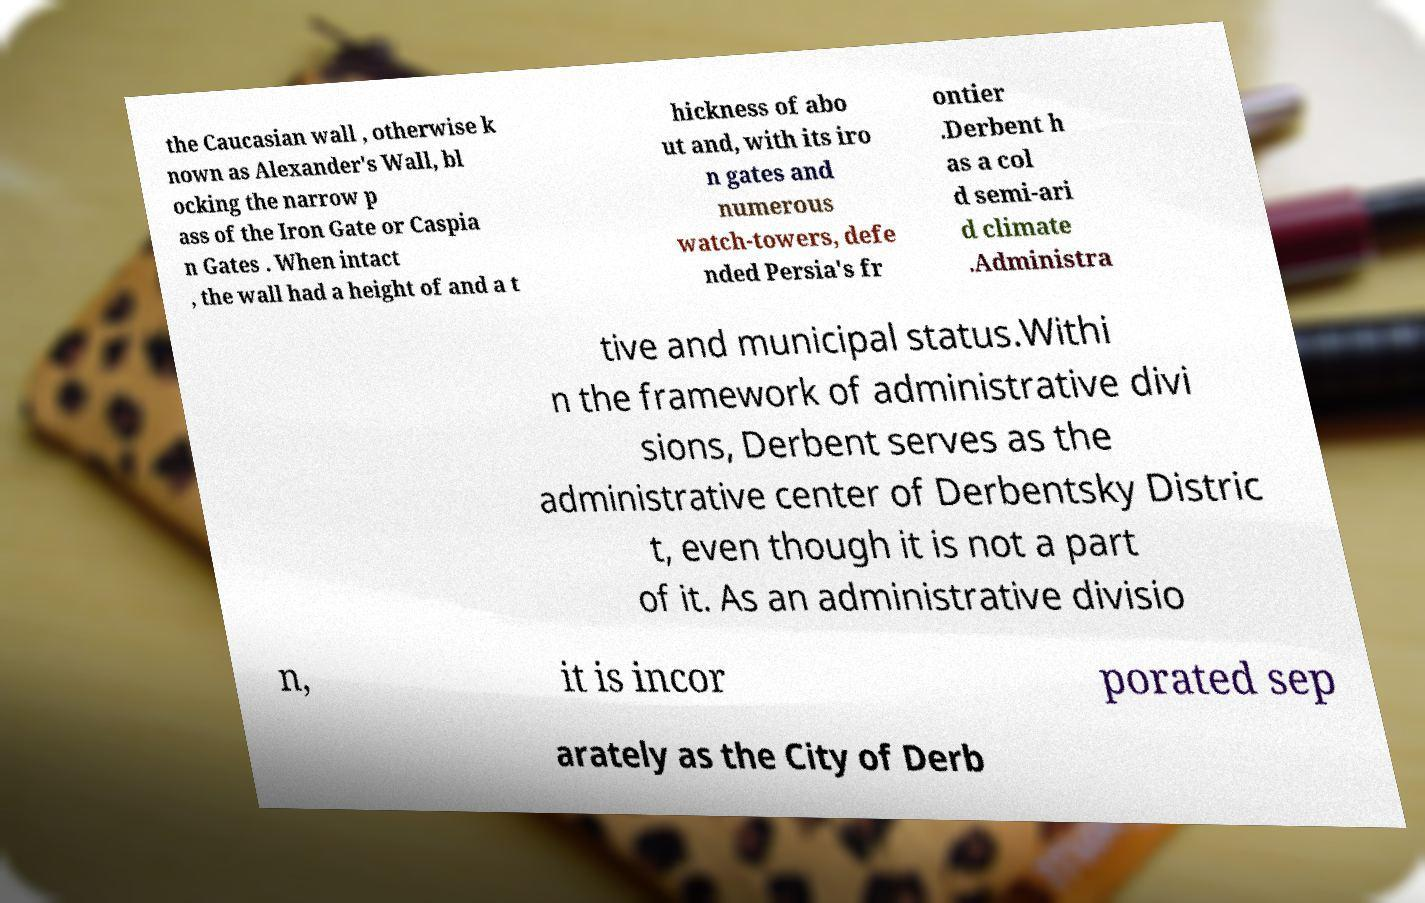Please read and relay the text visible in this image. What does it say? the Caucasian wall , otherwise k nown as Alexander's Wall, bl ocking the narrow p ass of the Iron Gate or Caspia n Gates . When intact , the wall had a height of and a t hickness of abo ut and, with its iro n gates and numerous watch-towers, defe nded Persia's fr ontier .Derbent h as a col d semi-ari d climate .Administra tive and municipal status.Withi n the framework of administrative divi sions, Derbent serves as the administrative center of Derbentsky Distric t, even though it is not a part of it. As an administrative divisio n, it is incor porated sep arately as the City of Derb 